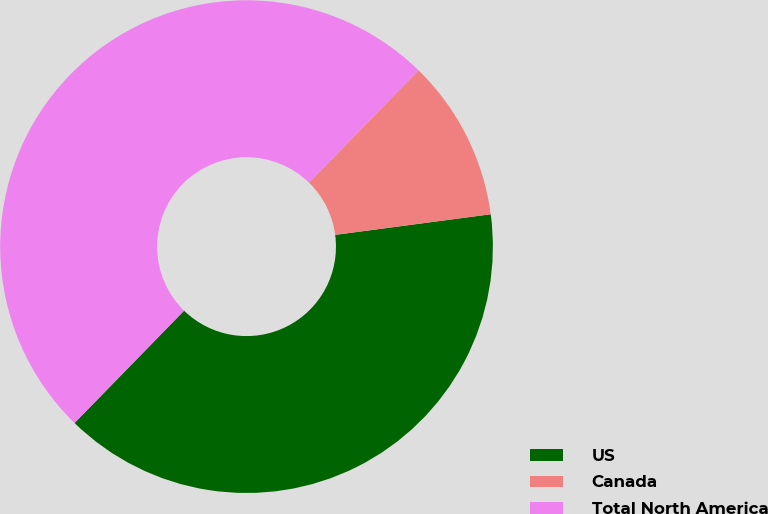<chart> <loc_0><loc_0><loc_500><loc_500><pie_chart><fcel>US<fcel>Canada<fcel>Total North America<nl><fcel>39.4%<fcel>10.6%<fcel>50.0%<nl></chart> 